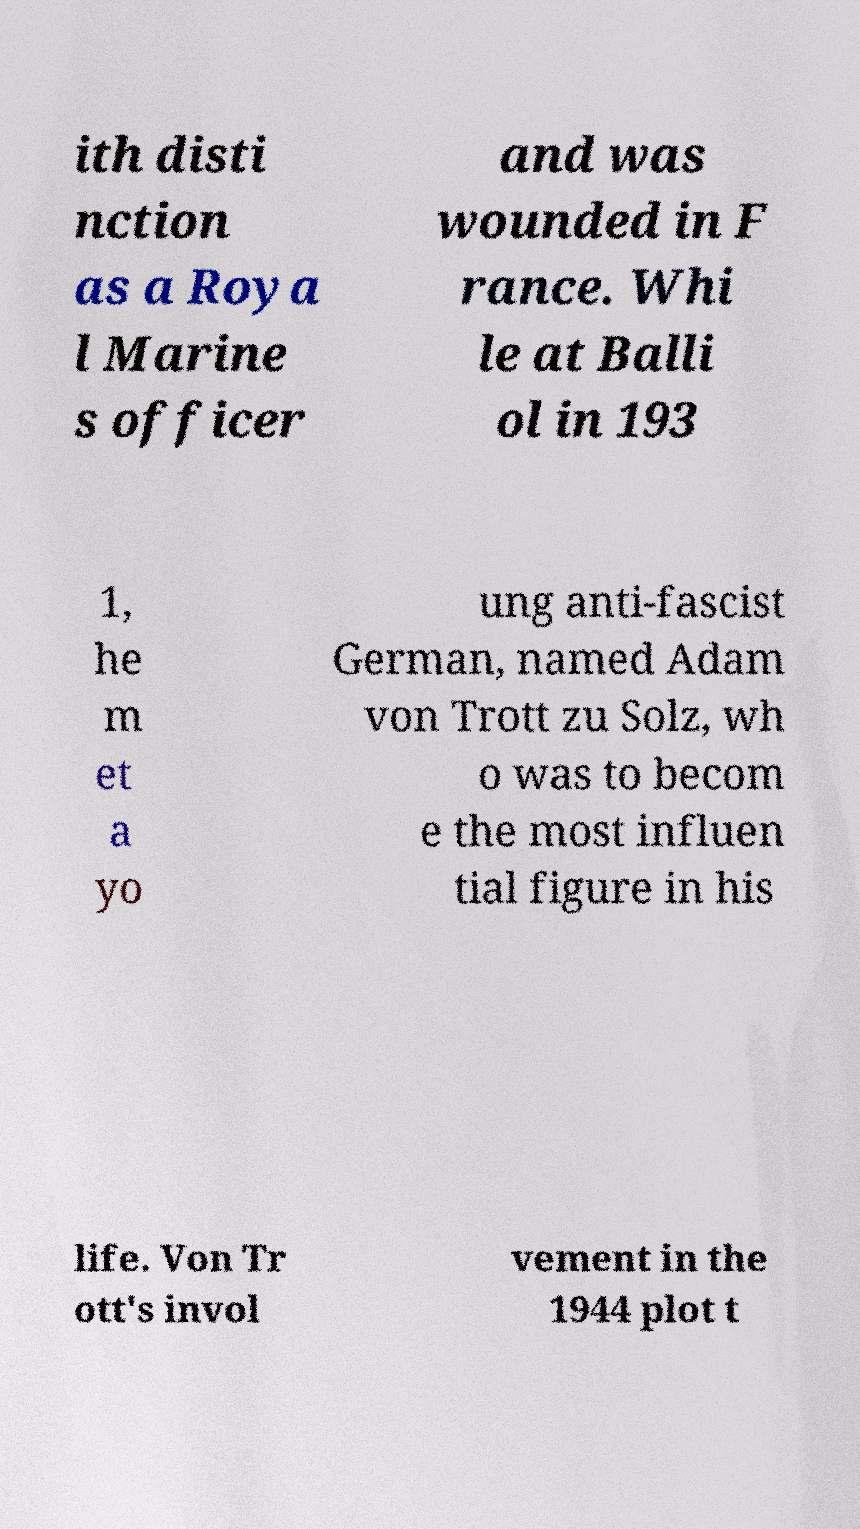Could you extract and type out the text from this image? ith disti nction as a Roya l Marine s officer and was wounded in F rance. Whi le at Balli ol in 193 1, he m et a yo ung anti-fascist German, named Adam von Trott zu Solz, wh o was to becom e the most influen tial figure in his life. Von Tr ott's invol vement in the 1944 plot t 